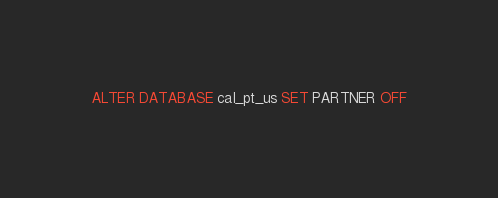Convert code to text. <code><loc_0><loc_0><loc_500><loc_500><_SQL_>ALTER DATABASE cal_pt_us SET PARTNER OFF</code> 